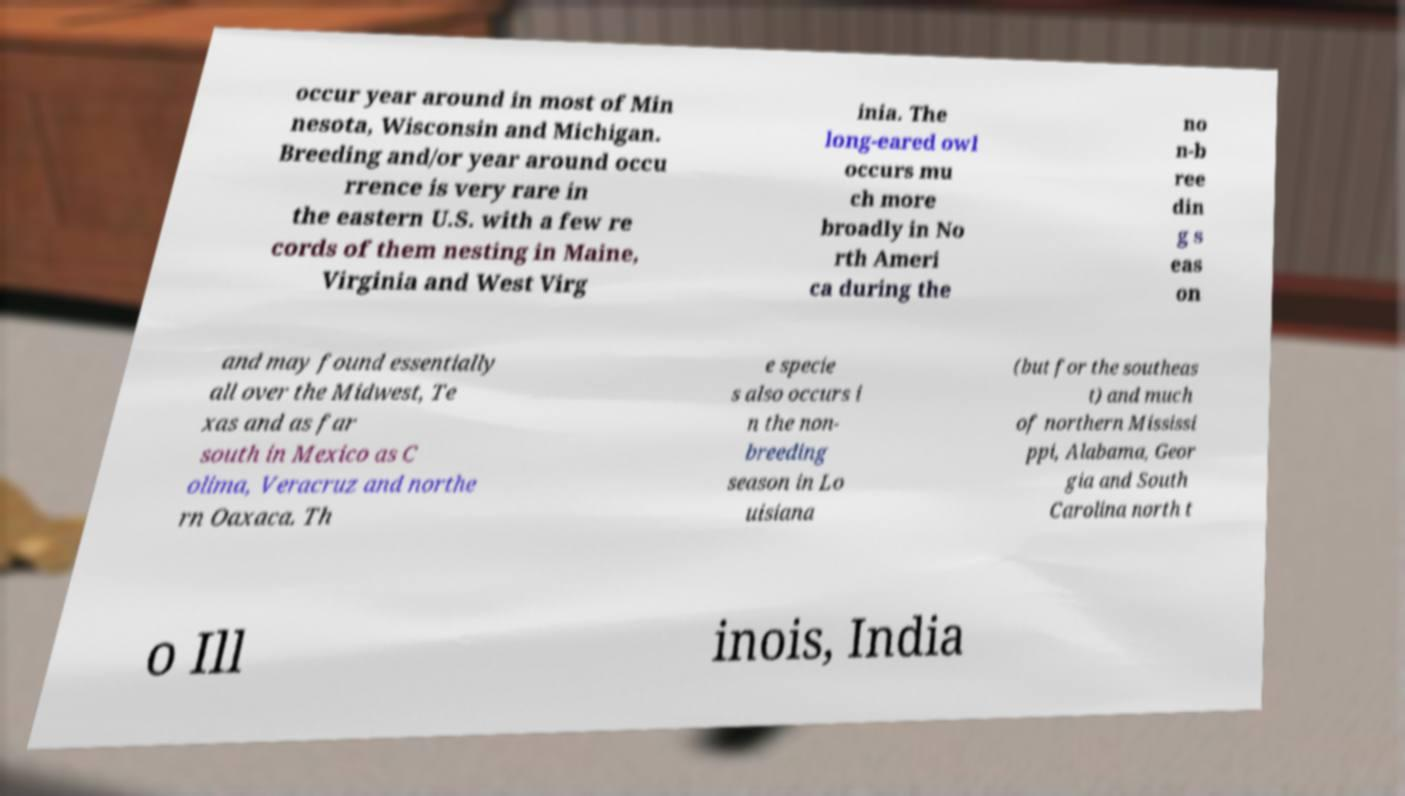Please identify and transcribe the text found in this image. occur year around in most of Min nesota, Wisconsin and Michigan. Breeding and/or year around occu rrence is very rare in the eastern U.S. with a few re cords of them nesting in Maine, Virginia and West Virg inia. The long-eared owl occurs mu ch more broadly in No rth Ameri ca during the no n-b ree din g s eas on and may found essentially all over the Midwest, Te xas and as far south in Mexico as C olima, Veracruz and northe rn Oaxaca. Th e specie s also occurs i n the non- breeding season in Lo uisiana (but for the southeas t) and much of northern Mississi ppi, Alabama, Geor gia and South Carolina north t o Ill inois, India 